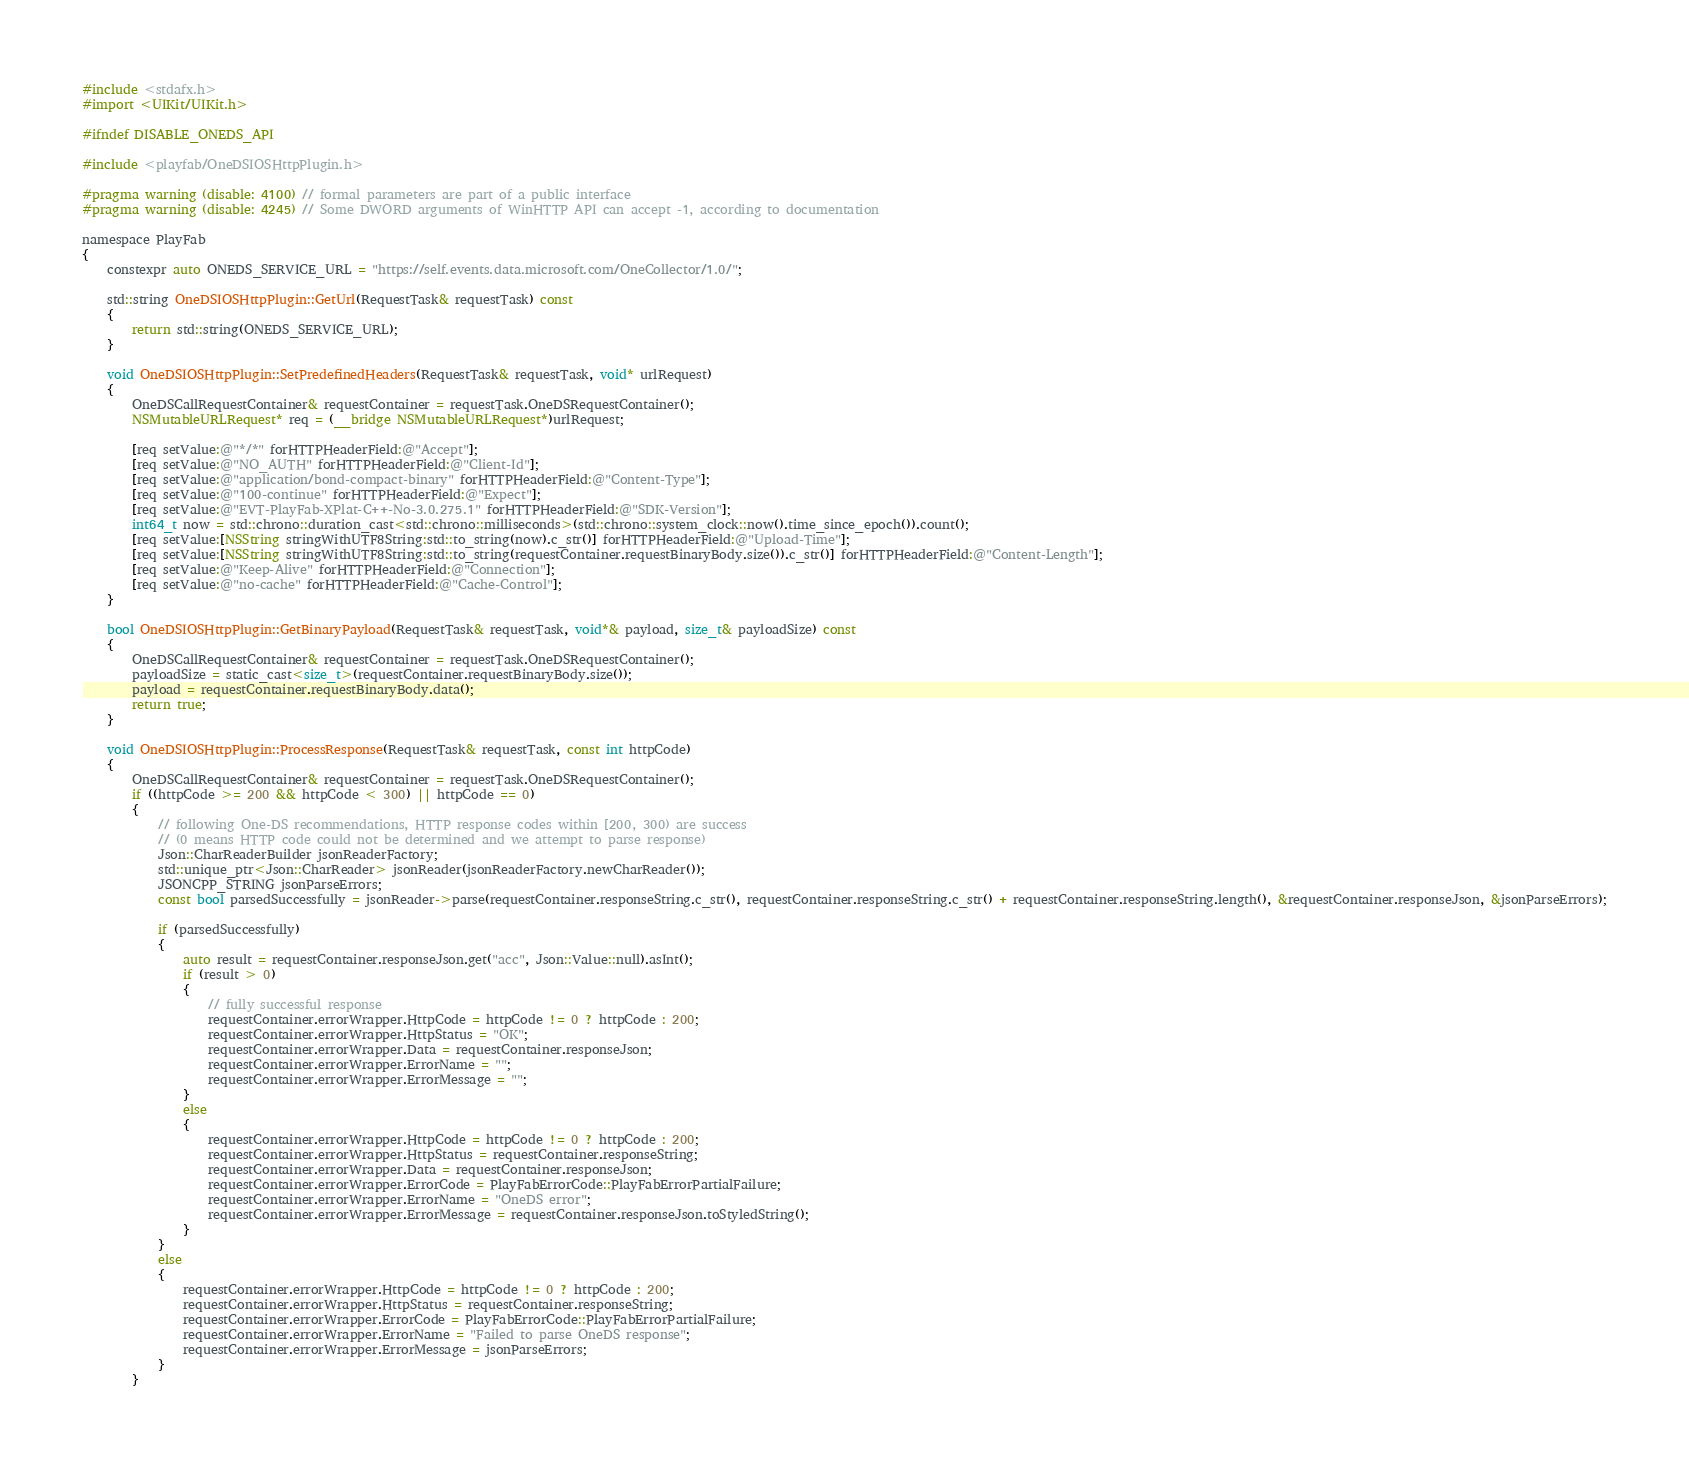<code> <loc_0><loc_0><loc_500><loc_500><_ObjectiveC_>#include <stdafx.h>
#import <UIKit/UIKit.h>

#ifndef DISABLE_ONEDS_API

#include <playfab/OneDSIOSHttpPlugin.h>

#pragma warning (disable: 4100) // formal parameters are part of a public interface
#pragma warning (disable: 4245) // Some DWORD arguments of WinHTTP API can accept -1, according to documentation

namespace PlayFab
{
    constexpr auto ONEDS_SERVICE_URL = "https://self.events.data.microsoft.com/OneCollector/1.0/";

    std::string OneDSIOSHttpPlugin::GetUrl(RequestTask& requestTask) const
    {
        return std::string(ONEDS_SERVICE_URL);
    }

    void OneDSIOSHttpPlugin::SetPredefinedHeaders(RequestTask& requestTask, void* urlRequest)
    {
        OneDSCallRequestContainer& requestContainer = requestTask.OneDSRequestContainer();
        NSMutableURLRequest* req = (__bridge NSMutableURLRequest*)urlRequest;

        [req setValue:@"*/*" forHTTPHeaderField:@"Accept"];
        [req setValue:@"NO_AUTH" forHTTPHeaderField:@"Client-Id"];
        [req setValue:@"application/bond-compact-binary" forHTTPHeaderField:@"Content-Type"];
        [req setValue:@"100-continue" forHTTPHeaderField:@"Expect"];
        [req setValue:@"EVT-PlayFab-XPlat-C++-No-3.0.275.1" forHTTPHeaderField:@"SDK-Version"];
        int64_t now = std::chrono::duration_cast<std::chrono::milliseconds>(std::chrono::system_clock::now().time_since_epoch()).count();
        [req setValue:[NSString stringWithUTF8String:std::to_string(now).c_str()] forHTTPHeaderField:@"Upload-Time"];
        [req setValue:[NSString stringWithUTF8String:std::to_string(requestContainer.requestBinaryBody.size()).c_str()] forHTTPHeaderField:@"Content-Length"];
        [req setValue:@"Keep-Alive" forHTTPHeaderField:@"Connection"];
        [req setValue:@"no-cache" forHTTPHeaderField:@"Cache-Control"];
    }

    bool OneDSIOSHttpPlugin::GetBinaryPayload(RequestTask& requestTask, void*& payload, size_t& payloadSize) const
    {
        OneDSCallRequestContainer& requestContainer = requestTask.OneDSRequestContainer();
        payloadSize = static_cast<size_t>(requestContainer.requestBinaryBody.size());
        payload = requestContainer.requestBinaryBody.data();
        return true;
    }

    void OneDSIOSHttpPlugin::ProcessResponse(RequestTask& requestTask, const int httpCode)
    {
        OneDSCallRequestContainer& requestContainer = requestTask.OneDSRequestContainer();
        if ((httpCode >= 200 && httpCode < 300) || httpCode == 0)
        {
            // following One-DS recommendations, HTTP response codes within [200, 300) are success
            // (0 means HTTP code could not be determined and we attempt to parse response)
            Json::CharReaderBuilder jsonReaderFactory;
            std::unique_ptr<Json::CharReader> jsonReader(jsonReaderFactory.newCharReader());
            JSONCPP_STRING jsonParseErrors;
            const bool parsedSuccessfully = jsonReader->parse(requestContainer.responseString.c_str(), requestContainer.responseString.c_str() + requestContainer.responseString.length(), &requestContainer.responseJson, &jsonParseErrors);

            if (parsedSuccessfully)
            {
                auto result = requestContainer.responseJson.get("acc", Json::Value::null).asInt();
                if (result > 0)
                {
                    // fully successful response
                    requestContainer.errorWrapper.HttpCode = httpCode != 0 ? httpCode : 200;
                    requestContainer.errorWrapper.HttpStatus = "OK";
                    requestContainer.errorWrapper.Data = requestContainer.responseJson;
                    requestContainer.errorWrapper.ErrorName = "";
                    requestContainer.errorWrapper.ErrorMessage = "";
                }
                else
                {
                    requestContainer.errorWrapper.HttpCode = httpCode != 0 ? httpCode : 200;
                    requestContainer.errorWrapper.HttpStatus = requestContainer.responseString;
                    requestContainer.errorWrapper.Data = requestContainer.responseJson;
                    requestContainer.errorWrapper.ErrorCode = PlayFabErrorCode::PlayFabErrorPartialFailure;
                    requestContainer.errorWrapper.ErrorName = "OneDS error";
                    requestContainer.errorWrapper.ErrorMessage = requestContainer.responseJson.toStyledString();
                }
            }
            else
            {
                requestContainer.errorWrapper.HttpCode = httpCode != 0 ? httpCode : 200;
                requestContainer.errorWrapper.HttpStatus = requestContainer.responseString;
                requestContainer.errorWrapper.ErrorCode = PlayFabErrorCode::PlayFabErrorPartialFailure;
                requestContainer.errorWrapper.ErrorName = "Failed to parse OneDS response";
                requestContainer.errorWrapper.ErrorMessage = jsonParseErrors;
            }
        }</code> 